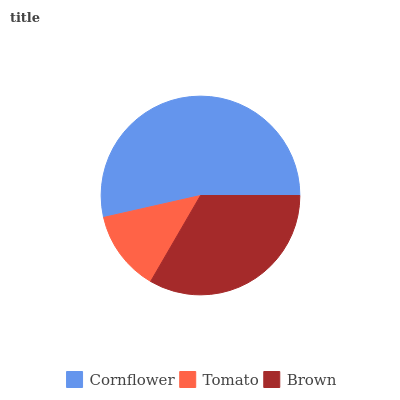Is Tomato the minimum?
Answer yes or no. Yes. Is Cornflower the maximum?
Answer yes or no. Yes. Is Brown the minimum?
Answer yes or no. No. Is Brown the maximum?
Answer yes or no. No. Is Brown greater than Tomato?
Answer yes or no. Yes. Is Tomato less than Brown?
Answer yes or no. Yes. Is Tomato greater than Brown?
Answer yes or no. No. Is Brown less than Tomato?
Answer yes or no. No. Is Brown the high median?
Answer yes or no. Yes. Is Brown the low median?
Answer yes or no. Yes. Is Cornflower the high median?
Answer yes or no. No. Is Cornflower the low median?
Answer yes or no. No. 